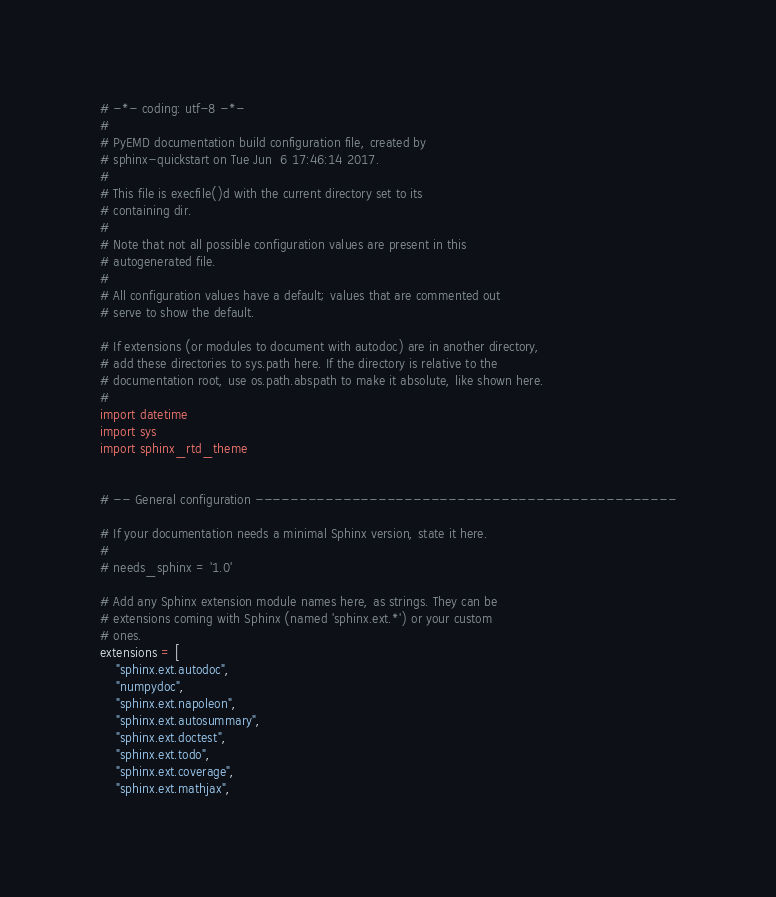<code> <loc_0><loc_0><loc_500><loc_500><_Python_># -*- coding: utf-8 -*-
#
# PyEMD documentation build configuration file, created by
# sphinx-quickstart on Tue Jun  6 17:46:14 2017.
#
# This file is execfile()d with the current directory set to its
# containing dir.
#
# Note that not all possible configuration values are present in this
# autogenerated file.
#
# All configuration values have a default; values that are commented out
# serve to show the default.

# If extensions (or modules to document with autodoc) are in another directory,
# add these directories to sys.path here. If the directory is relative to the
# documentation root, use os.path.abspath to make it absolute, like shown here.
#
import datetime
import sys
import sphinx_rtd_theme


# -- General configuration ------------------------------------------------

# If your documentation needs a minimal Sphinx version, state it here.
#
# needs_sphinx = '1.0'

# Add any Sphinx extension module names here, as strings. They can be
# extensions coming with Sphinx (named 'sphinx.ext.*') or your custom
# ones.
extensions = [
    "sphinx.ext.autodoc",
    "numpydoc",
    "sphinx.ext.napoleon",
    "sphinx.ext.autosummary",
    "sphinx.ext.doctest",
    "sphinx.ext.todo",
    "sphinx.ext.coverage",
    "sphinx.ext.mathjax",</code> 